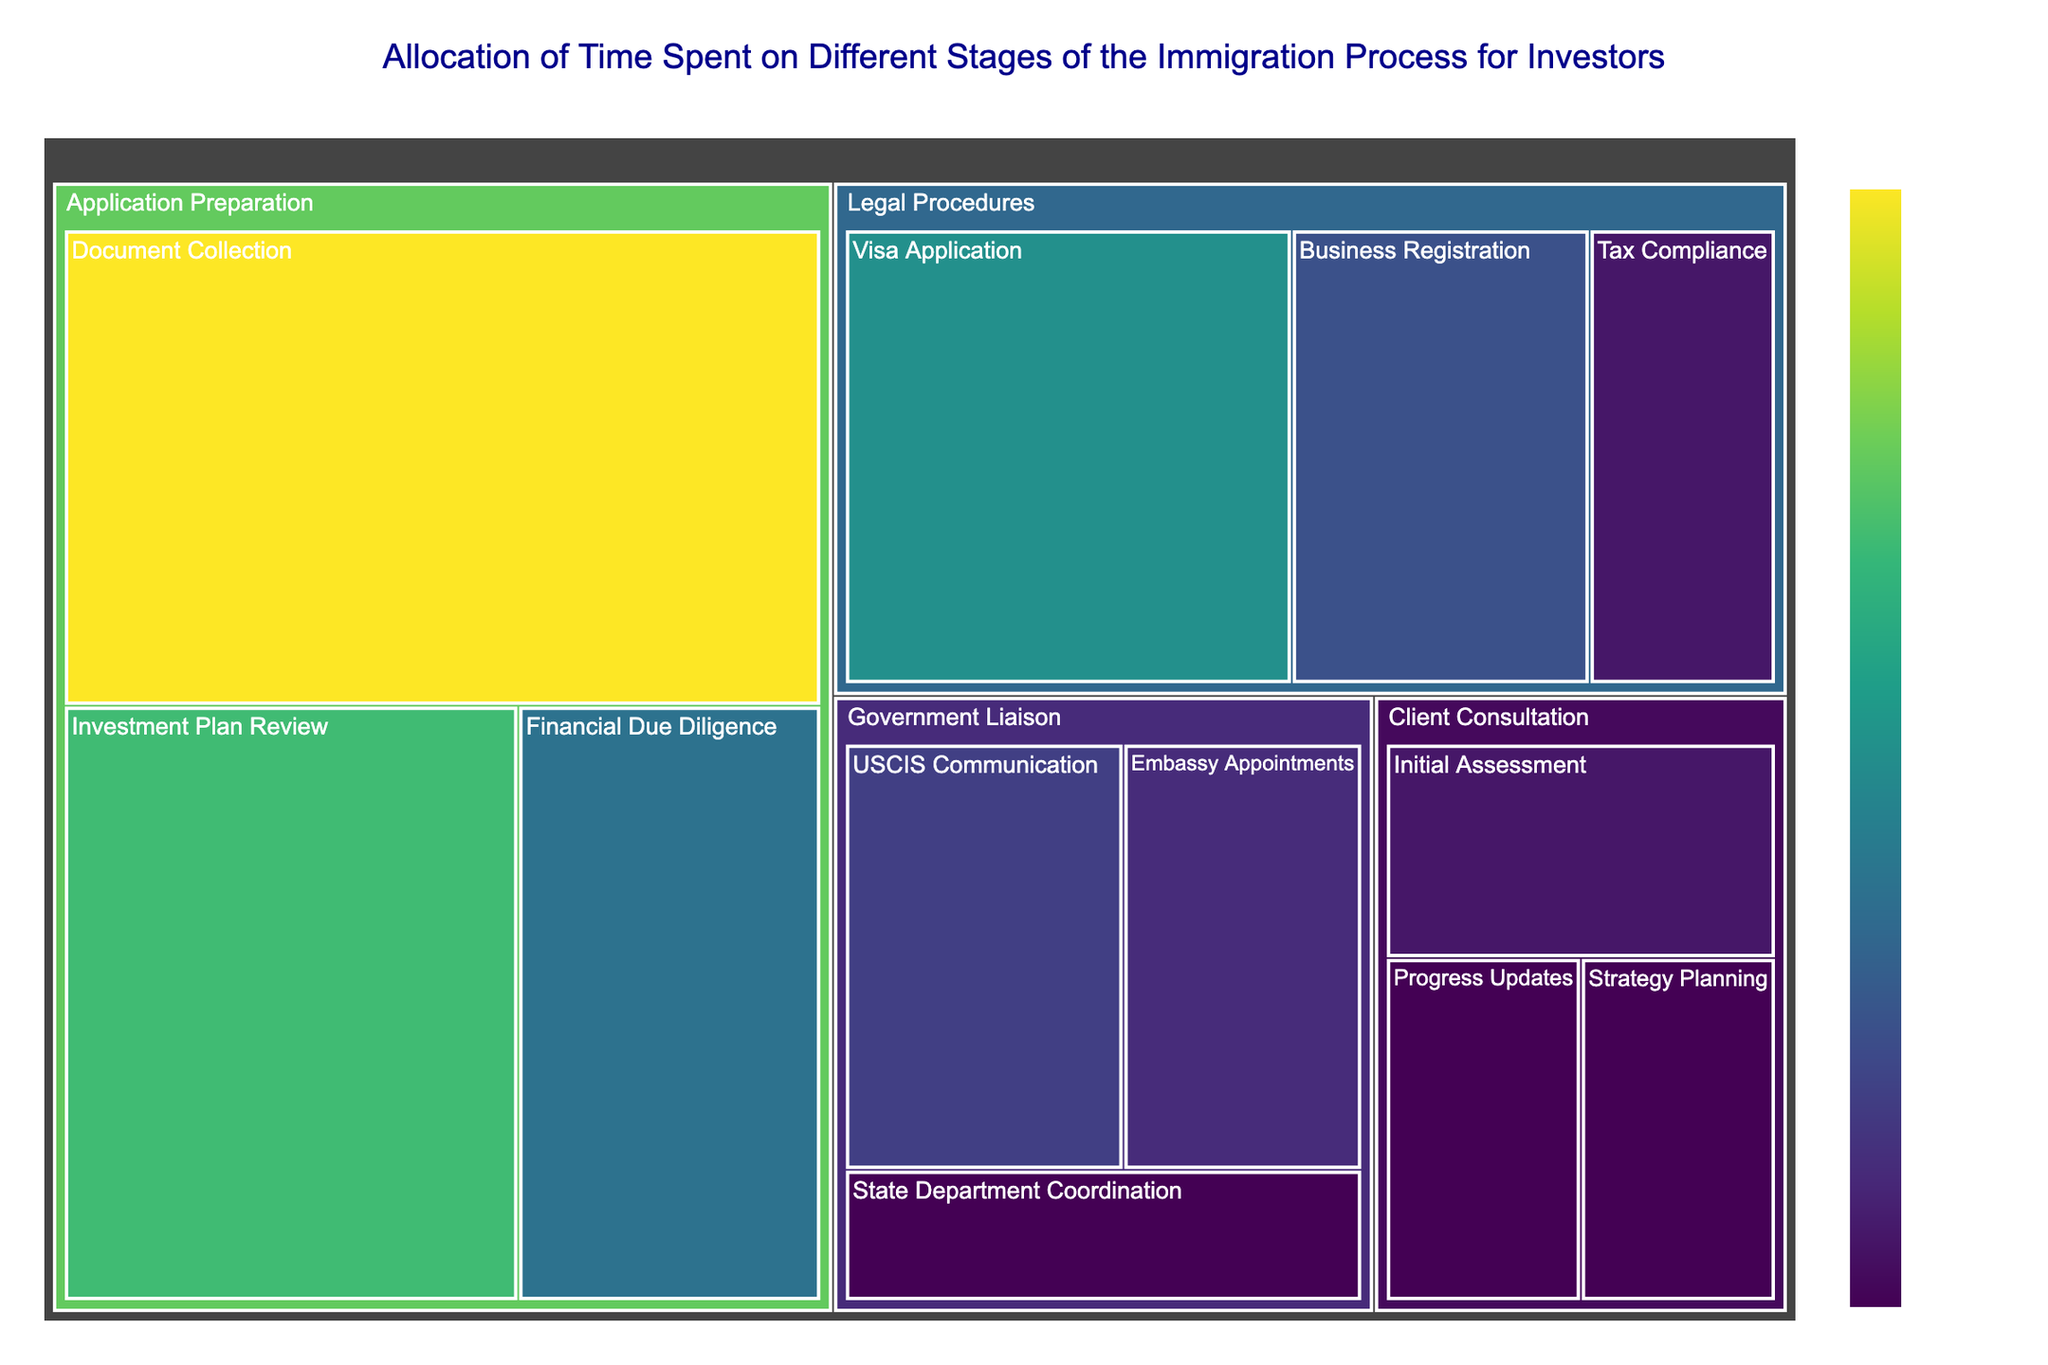What is the title of the Treemap? The title of the Treemap is displayed at the top of the figure and summarizes the main focus of the visualization.
Answer: Allocation of Time Spent on Different Stages of the Immigration Process for Investors Which stage has the highest time allocation? By looking at the overall size of the segments under each stage, the stage with the largest total value corresponds to the highest time allocation.
Answer: Application Preparation What is the total time allocated to the 'Legal Procedures' stage? To find the total time for 'Legal Procedures,' sum the time allocations of all tasks under it: Visa Application (12) + Business Registration (8) + Tax Compliance (5). Therefore, 12 + 8 + 5 = 25.
Answer: 25 Which task within the 'Government Liaison' stage has the least time allocation? Under the 'Government Liaison' stage, compare the time allocations of the tasks. The smallest segment will indicate the task with the least time allocation.
Answer: State Department Coordination Compare the time allocated to 'Document Collection' and 'Financial Due Diligence' within the 'Application Preparation' stage. Which one has more time allocated? In the 'Application Preparation' stage, refer to the time allocations for 'Document Collection' and 'Financial Due Diligence'. Compare 20 (Document Collection) and 10 (Financial Due Diligence).
Answer: Document Collection What is the combined time allocation for 'Client Consultation' and 'Government Liaison' stages? To find the combined time allocation, sum the total times for 'Client Consultation' and 'Government Liaison': Client Consultation (5+4+4=13) and Government Liaison (7+6+4=17). Thus, 13+17=30.
Answer: 30 Which stage has the fewest distinct tasks? Compare the number of distinct tasks under each stage while considering the labels in the diagram.
Answer: Client Consultation In the 'Application Preparation' stage, what percentage of time is allocated to 'Investment Plan Review'? To calculate the percentage, divide the time allocated for 'Investment Plan Review' by the total time for 'Application Preparation' and multiply by 100: (15 / (15+20+10)) * 100 = (15 / 45) * 100 ≈ 33.33%.
Answer: 33.33% What is the difference in time allocation between 'Initial Assessment' and 'Strategy Planning' under 'Client Consultation'? Compute the time allocation difference by subtracting the smaller value from the larger one: 5 (Initial Assessment) - 4 (Strategy Planning) = 1.
Answer: 1 Which task has the highest time allocation within the 'Application Preparation' stage? Compare the time allocations of all tasks within the 'Application Preparation' stage. The largest segment indicates the task with the highest time allocation.
Answer: Document Collection 